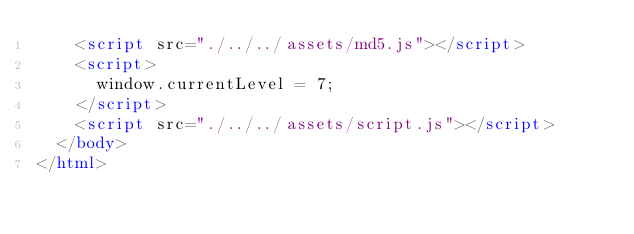<code> <loc_0><loc_0><loc_500><loc_500><_HTML_>    <script src="./../../assets/md5.js"></script>
    <script>
      window.currentLevel = 7;
    </script>
    <script src="./../../assets/script.js"></script>
  </body>
</html></code> 